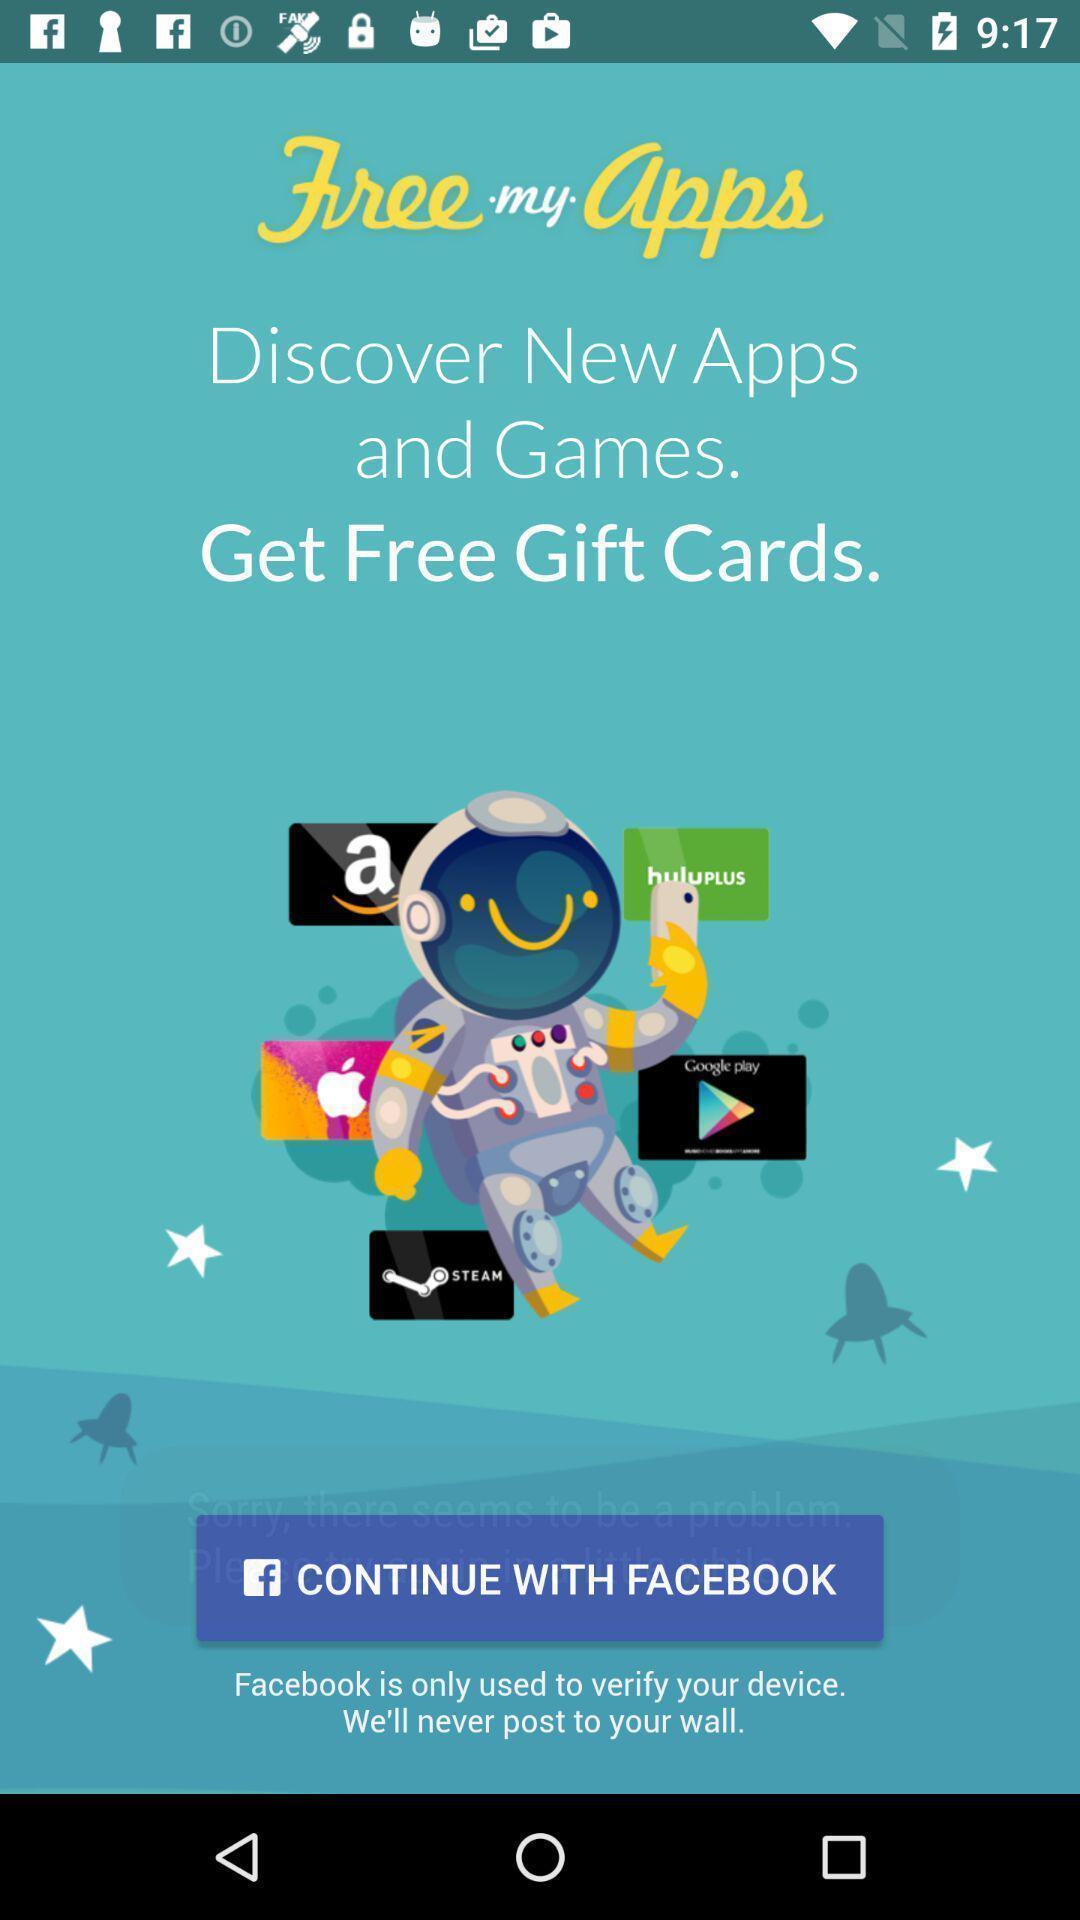Give me a narrative description of this picture. Welcome page. 